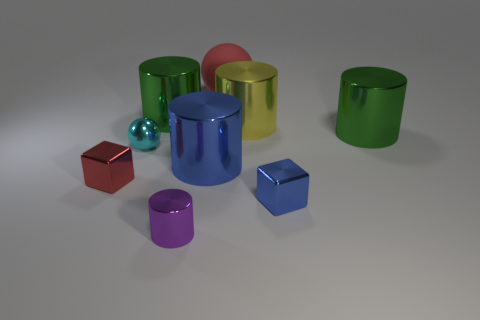Subtract all purple metal cylinders. How many cylinders are left? 4 Subtract all yellow cylinders. How many cylinders are left? 4 Subtract all cyan cylinders. Subtract all blue blocks. How many cylinders are left? 5 Add 1 green matte objects. How many objects exist? 10 Subtract all balls. How many objects are left? 7 Subtract 1 yellow cylinders. How many objects are left? 8 Subtract all red shiny cubes. Subtract all red metallic cubes. How many objects are left? 7 Add 4 small cylinders. How many small cylinders are left? 5 Add 4 green metallic cylinders. How many green metallic cylinders exist? 6 